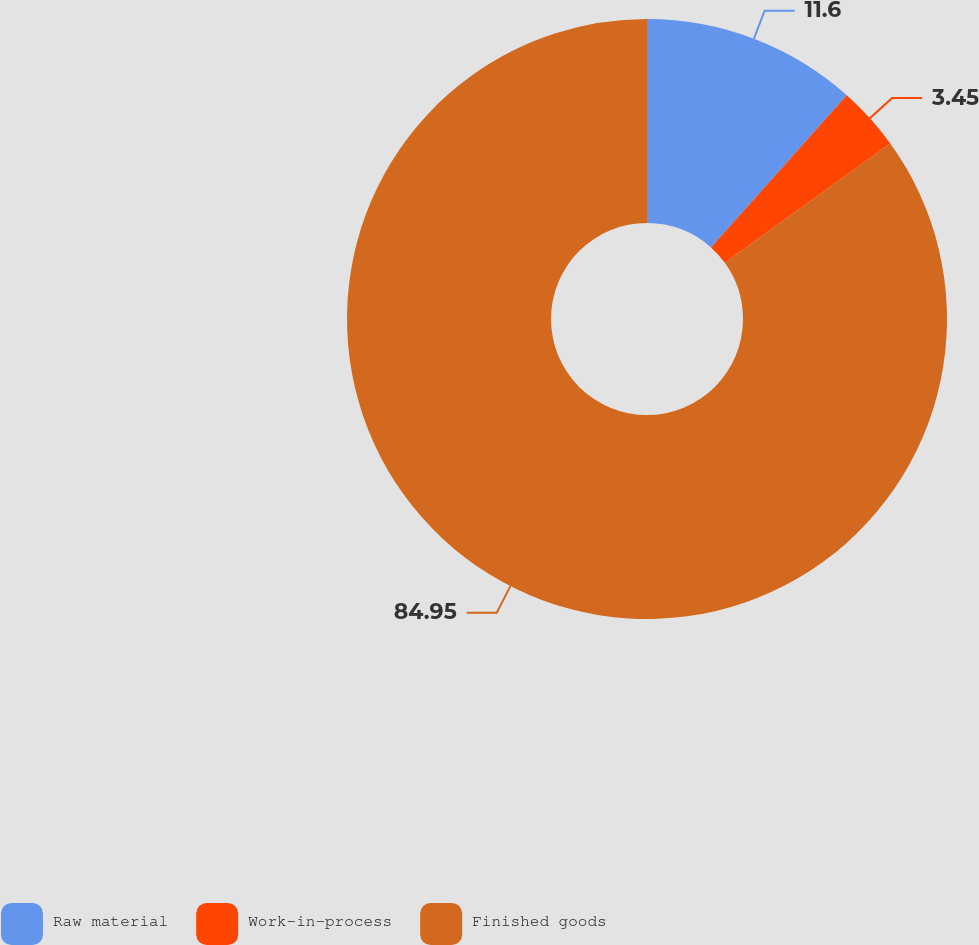Convert chart to OTSL. <chart><loc_0><loc_0><loc_500><loc_500><pie_chart><fcel>Raw material<fcel>Work-in-process<fcel>Finished goods<nl><fcel>11.6%<fcel>3.45%<fcel>84.95%<nl></chart> 